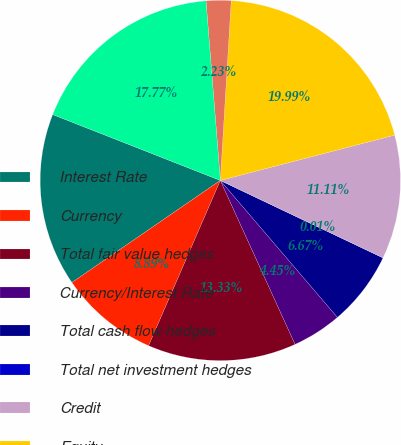Convert chart. <chart><loc_0><loc_0><loc_500><loc_500><pie_chart><fcel>Interest Rate<fcel>Currency<fcel>Total fair value hedges<fcel>Currency/Interest Rate<fcel>Total cash flow hedges<fcel>Total net investment hedges<fcel>Credit<fcel>Equity<fcel>Other<fcel>Embedded Derivatives<nl><fcel>15.55%<fcel>8.89%<fcel>13.33%<fcel>4.45%<fcel>6.67%<fcel>0.01%<fcel>11.11%<fcel>19.99%<fcel>2.23%<fcel>17.77%<nl></chart> 